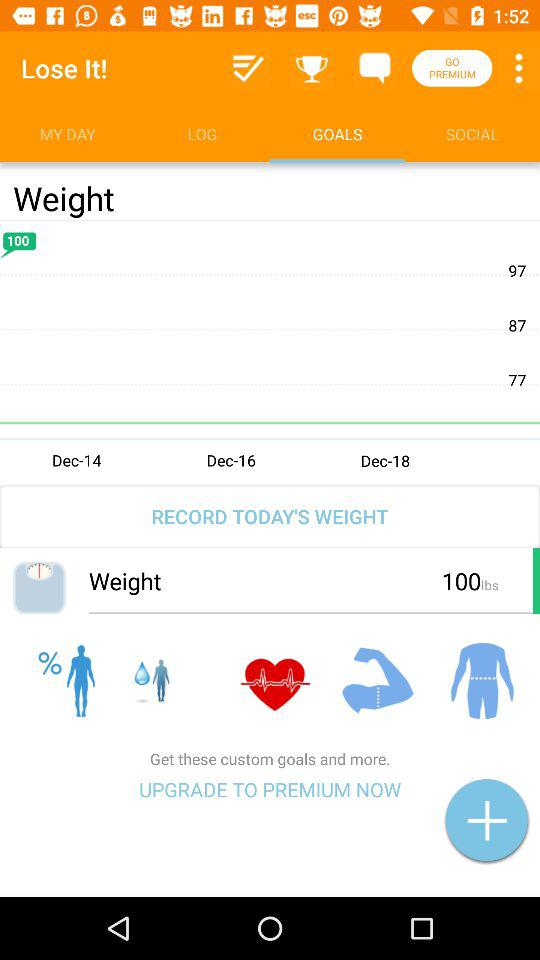Which tab is selected? The selected tab is "GOALS". 